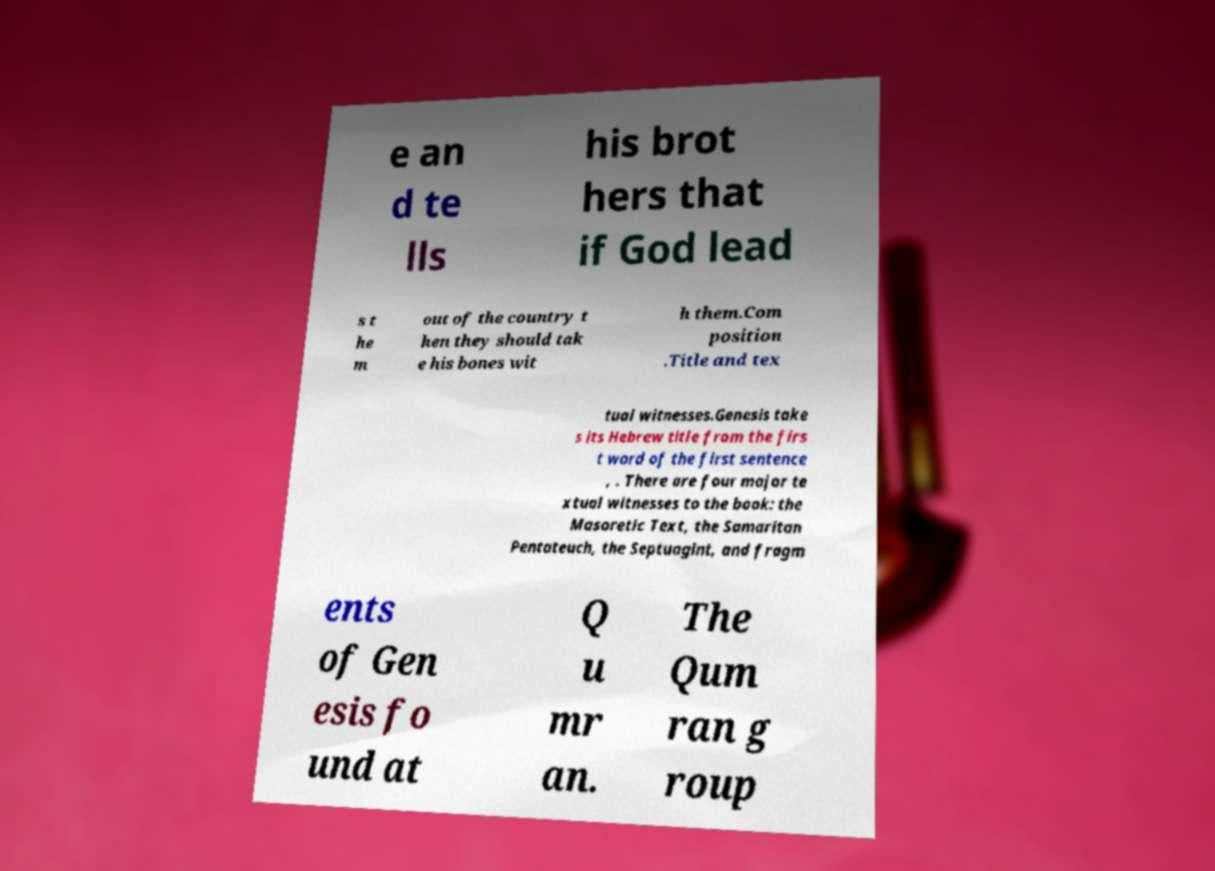Please read and relay the text visible in this image. What does it say? e an d te lls his brot hers that if God lead s t he m out of the country t hen they should tak e his bones wit h them.Com position .Title and tex tual witnesses.Genesis take s its Hebrew title from the firs t word of the first sentence , . There are four major te xtual witnesses to the book: the Masoretic Text, the Samaritan Pentateuch, the Septuagint, and fragm ents of Gen esis fo und at Q u mr an. The Qum ran g roup 